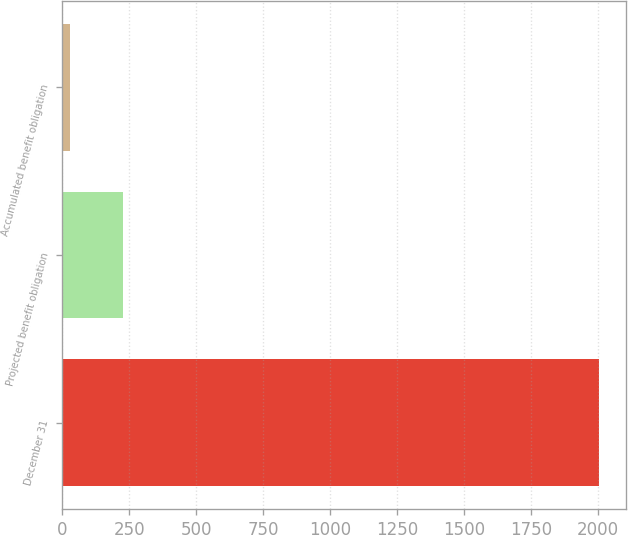<chart> <loc_0><loc_0><loc_500><loc_500><bar_chart><fcel>December 31<fcel>Projected benefit obligation<fcel>Accumulated benefit obligation<nl><fcel>2004<fcel>224.88<fcel>27.2<nl></chart> 